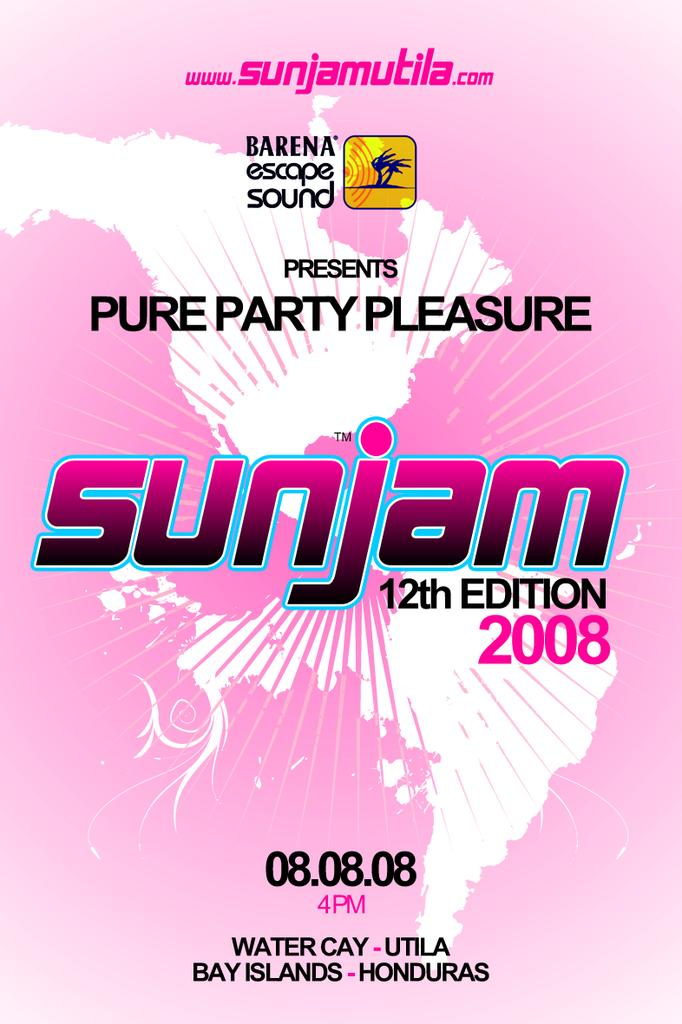<image>
Create a compact narrative representing the image presented. a poster that has the word sunjam on it 